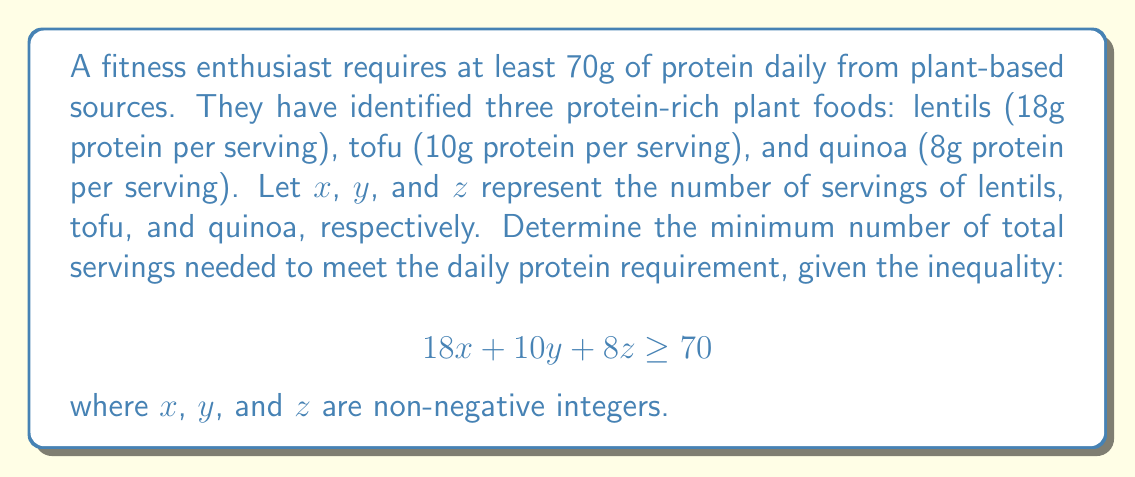Give your solution to this math problem. 1) We need to minimize $x + y + z$ subject to the constraint $18x + 10y + 8z \geq 70$ and $x, y, z \geq 0$ (and integers).

2) To minimize the total number of servings, we should prioritize the food with the highest protein content per serving (lentils), then the second highest (tofu), and so on.

3) Start with lentils:
   $18x \geq 70$
   $x \geq 3.89$
   Since $x$ must be an integer, $x = 4$

4) With 4 servings of lentils:
   $18(4) = 72 > 70$

5) Therefore, the minimum solution is 4 servings of lentils, which satisfies the inequality:
   $18(4) + 10(0) + 8(0) = 72 \geq 70$

6) The total number of servings is $4 + 0 + 0 = 4$
Answer: 4 servings 